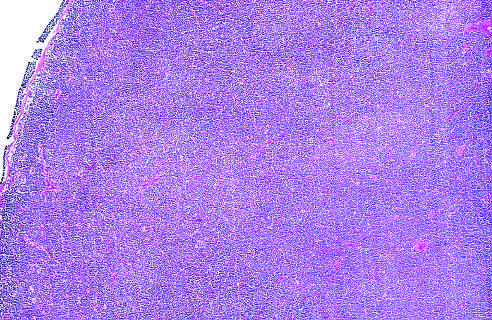does the low-power view show diffuse effacement of nodal architecture?
Answer the question using a single word or phrase. Yes 